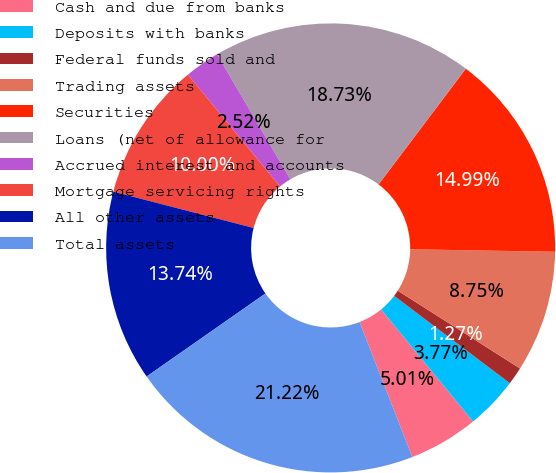Convert chart. <chart><loc_0><loc_0><loc_500><loc_500><pie_chart><fcel>Cash and due from banks<fcel>Deposits with banks<fcel>Federal funds sold and<fcel>Trading assets<fcel>Securities<fcel>Loans (net of allowance for<fcel>Accrued interest and accounts<fcel>Mortgage servicing rights<fcel>All other assets<fcel>Total assets<nl><fcel>5.01%<fcel>3.77%<fcel>1.27%<fcel>8.75%<fcel>14.99%<fcel>18.73%<fcel>2.52%<fcel>10.0%<fcel>13.74%<fcel>21.22%<nl></chart> 